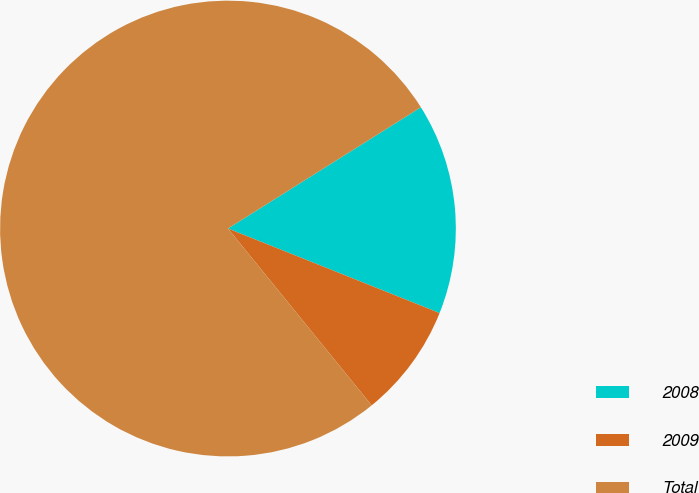Convert chart to OTSL. <chart><loc_0><loc_0><loc_500><loc_500><pie_chart><fcel>2008<fcel>2009<fcel>Total<nl><fcel>14.98%<fcel>8.09%<fcel>76.93%<nl></chart> 